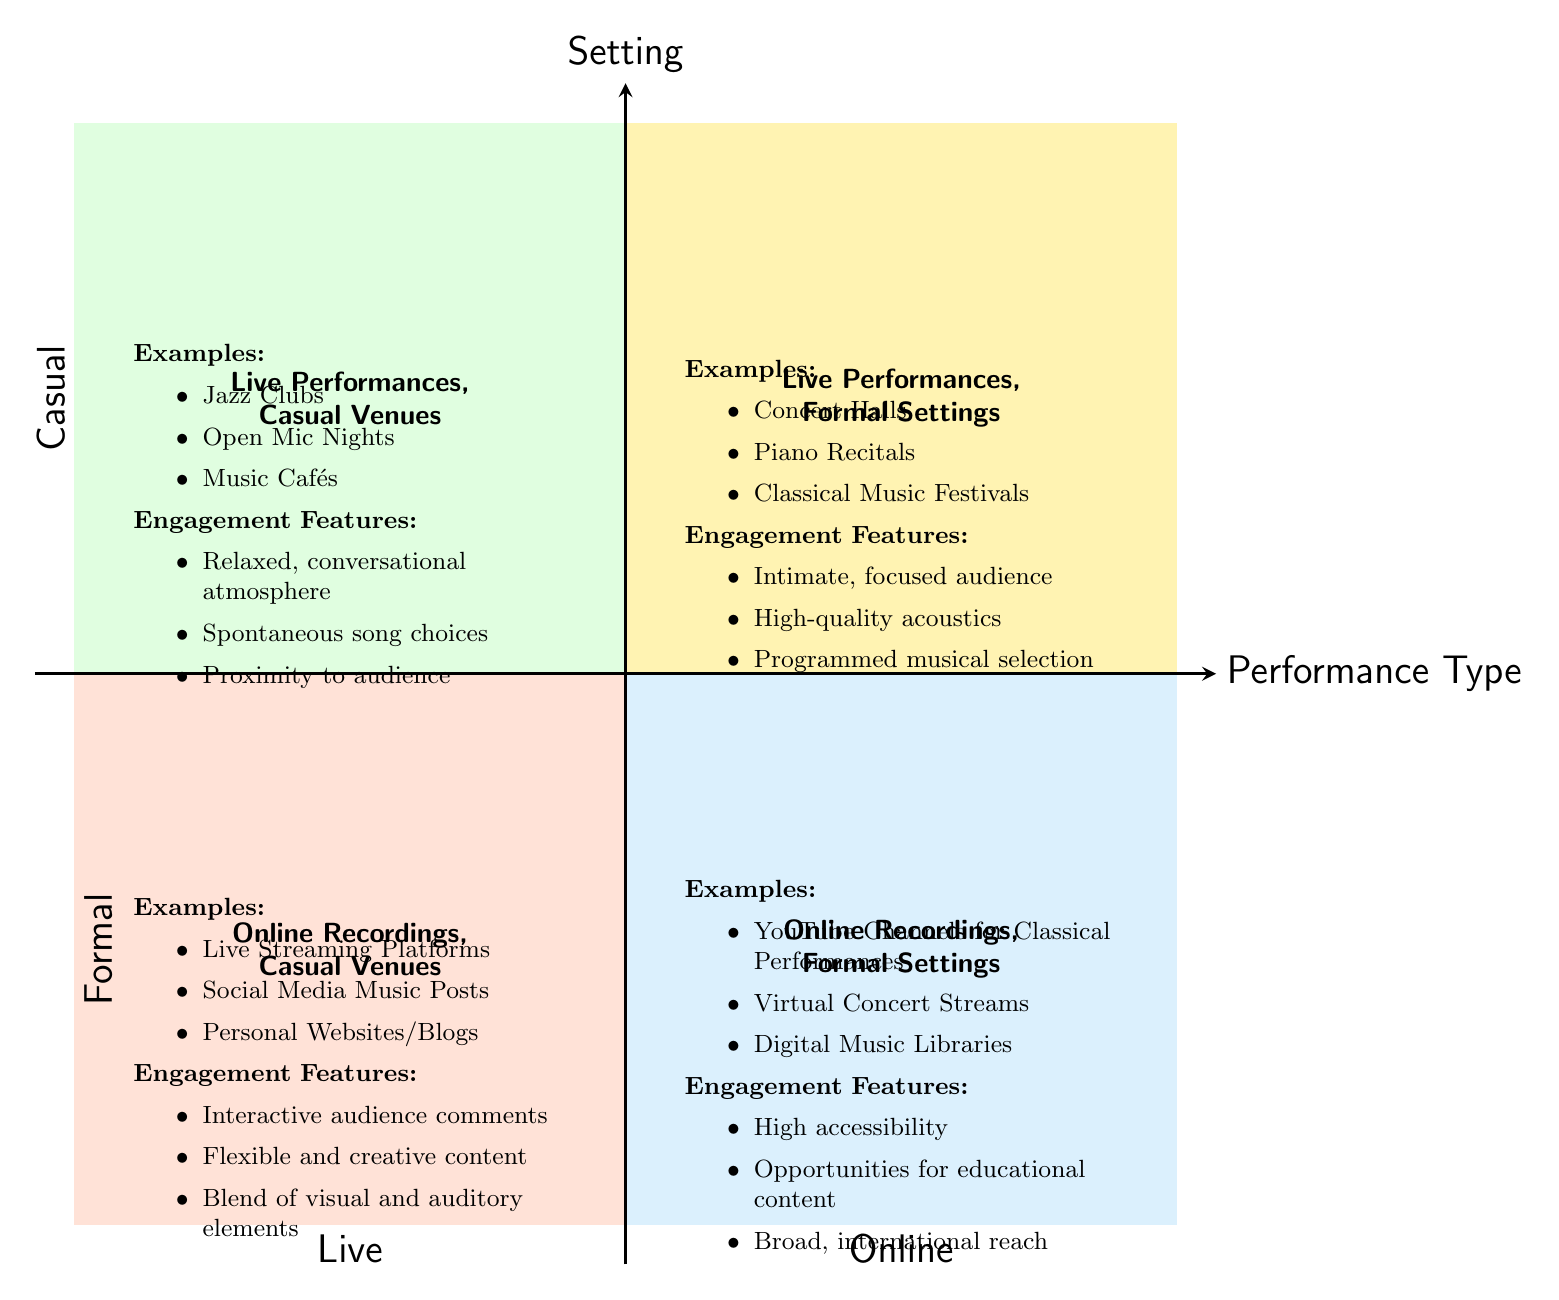What examples are listed in the "Live Performances, Casual Venues" quadrant? The "Live Performances, Casual Venues" quadrant has three examples: Jazz Clubs, Open Mic Nights, and Music Cafés.
Answer: Jazz Clubs, Open Mic Nights, Music Cafés What engagement feature is unique to the "Online Recordings, Casual Venues" quadrant? The "Online Recordings, Casual Venues" quadrant includes the engagement feature of interactive audience comments, which is focused on audience interaction in a non-formal setting.
Answer: Interactive audience comments How many quadrants are showing examples of formal settings? There are two quadrants that show examples of formal settings: "Live Performances, Formal Settings" and "Online Recordings, Formal Settings."
Answer: 2 Which quadrant features opportunities for educational content? The "Online Recordings, Formal Settings" quadrant includes opportunities for educational content as one of its engagement features, highlighting the informative aspect of formal online performances.
Answer: Online Recordings, Formal Settings What is the atmosphere described in the "Live Performances, Casual Venues" quadrant? The "Live Performances, Casual Venues" quadrant describes a relaxed, conversational atmosphere, which emphasizes the informal nature of the performances in that category.
Answer: Relaxed, conversational atmosphere Which quadrant has the highest accessibility as an engagement feature? The "Online Recordings, Formal Settings" quadrant features high accessibility as an engagement feature, which refers to the ease with which audiences can access the performances online.
Answer: High accessibility What is the primary difference in audience interaction between "Live Performances, Casual Venues" and "Online Recordings, Formal Settings"? The primary difference is that "Live Performances, Casual Venues" focus on a spontaneous interaction with a relaxed audience atmosphere, while "Online Recordings, Formal Settings" prioritize organized and educational content over direct interaction.
Answer: Spontaneous interaction vs Organized content Which quadrant is likely to have a wider audience reach? The "Online Recordings, Formal Settings" quadrant is likely to have a broader international reach due to the digital nature of the performances that can be accessed from anywhere.
Answer: Online Recordings, Formal Settings 